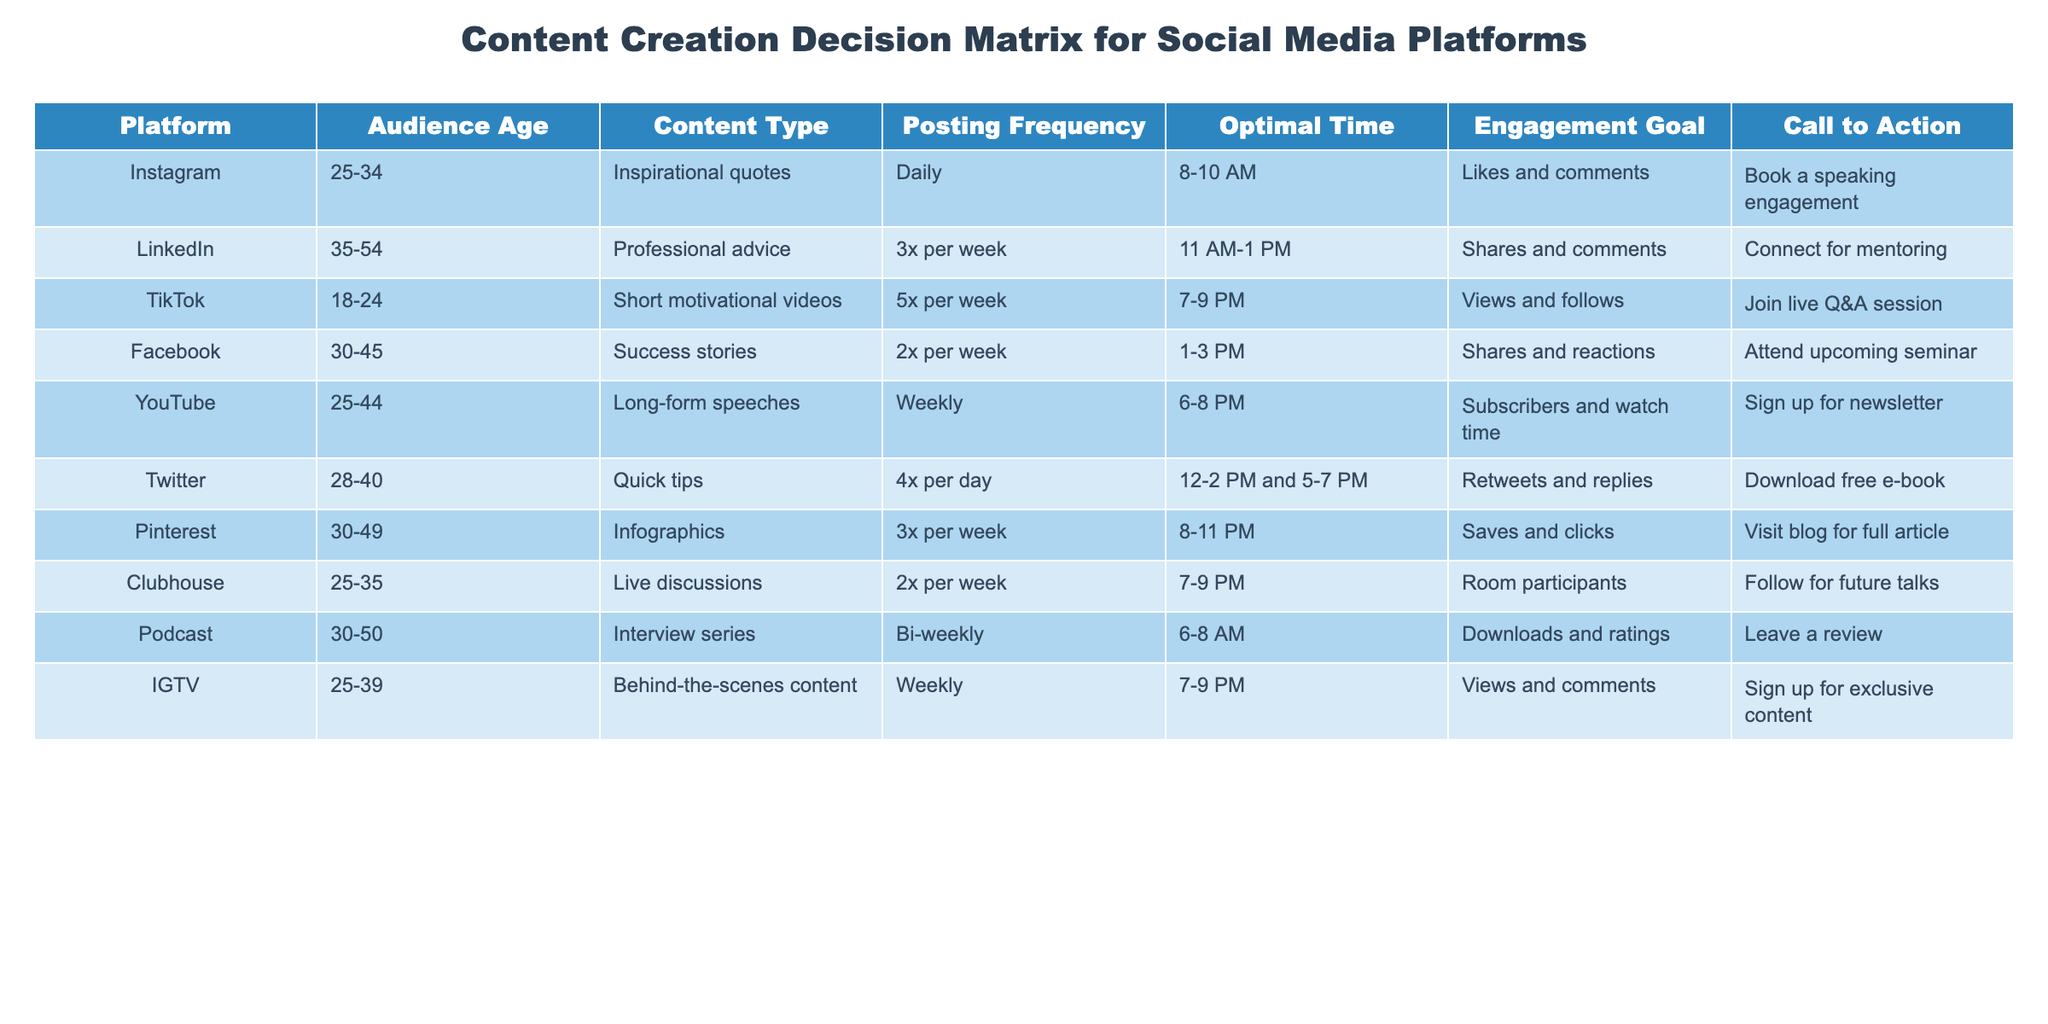What is the posting frequency for TikTok? The table indicates that TikTok has a posting frequency of 5 times per week. This information is found directly under the "Posting Frequency" column for the TikTok row.
Answer: 5x per week What is the optimal time to post on Twitter? Looking at the "Optimal Time" column for Twitter, it shows that the best times to post are between 12-2 PM and 5-7 PM. This information can be retrieved directly from the table.
Answer: 12-2 PM and 5-7 PM Does Facebook focus on engagement through likes or shares? The table shows that Facebook sets its engagement goal on shares and reactions, indicating a focus on shares rather than just likes. Thus, the answer is no for likes being the main engagement goal.
Answer: No Which content type is targeted at the youngest audience? By scanning through the "Audience Age" column, we find that TikTok targets the age group 18-24, which is the youngest audience listed in the table. This is further verified by checking the corresponding "Content Type" for TikTok.
Answer: Short motivational videos What is the average audience age range for platforms that focus on professional advice? The table lists only LinkedIn under platforms targeting professional advice, which has an audience age range of 35-54. Therefore, the average age range for this category is simply the same as that listed for LinkedIn.
Answer: 35-54 Are motivational quotes used as a content type on Instagram? The data in the "Content Type" column for Instagram confirms that it indeed uses inspirational quotes as a content type. Thus, the answer is yes.
Answer: Yes Which platform has the highest posting frequency and what is that frequency? By reviewing the "Posting Frequency" column for all platforms, TikTok has the highest frequency at 5 times per week. This is the only platform listed with this frequency.
Answer: 5x per week Which Call to Action is associated with YouTube? The "Call to Action" column for YouTube indicates that the action linked to it is "Sign up for newsletter." This can be confirmed directly from the specific row in the table.
Answer: Sign up for newsletter How many platforms post weekly? The table shows that YouTube and IGTV both post weekly, totaling two platforms that have this frequency. This can be computed by counting the "Weekly" entries in the "Posting Frequency" column.
Answer: 2 platforms 